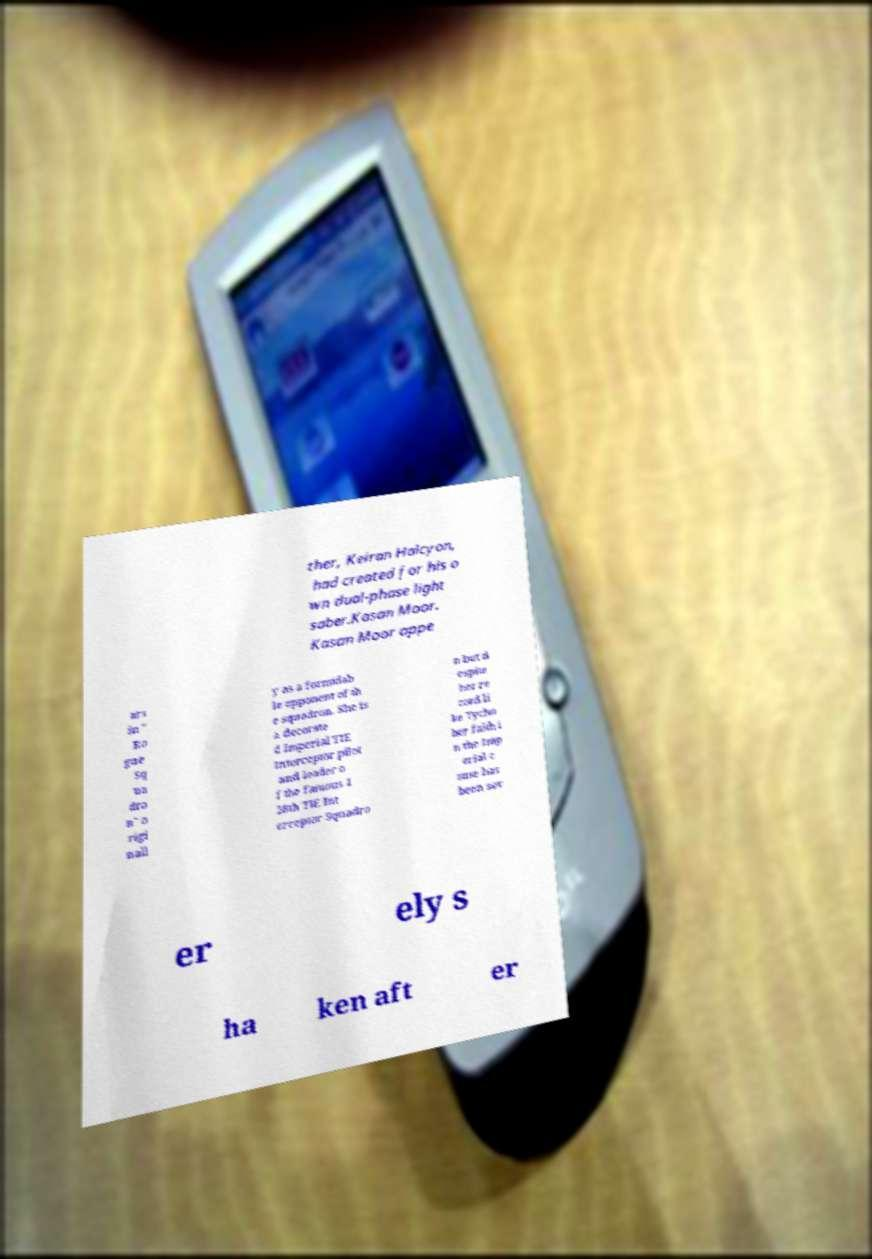What messages or text are displayed in this image? I need them in a readable, typed format. ther, Keiran Halcyon, had created for his o wn dual-phase light saber.Kasan Moor. Kasan Moor appe ars in " Ro gue Sq ua dro n" o rigi nall y as a formidab le opponent of th e squadron. She is a decorate d Imperial TIE Interceptor pilot and leader o f the famous 1 28th TIE Int erceptor Squadro n but d espite her re cord li ke Tycho her faith i n the Imp erial c ause has been sev er ely s ha ken aft er 